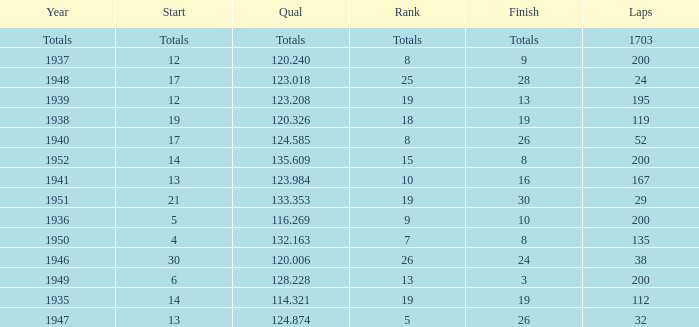With a Rank of 19, and a Start of 14, what was the finish? 19.0. 